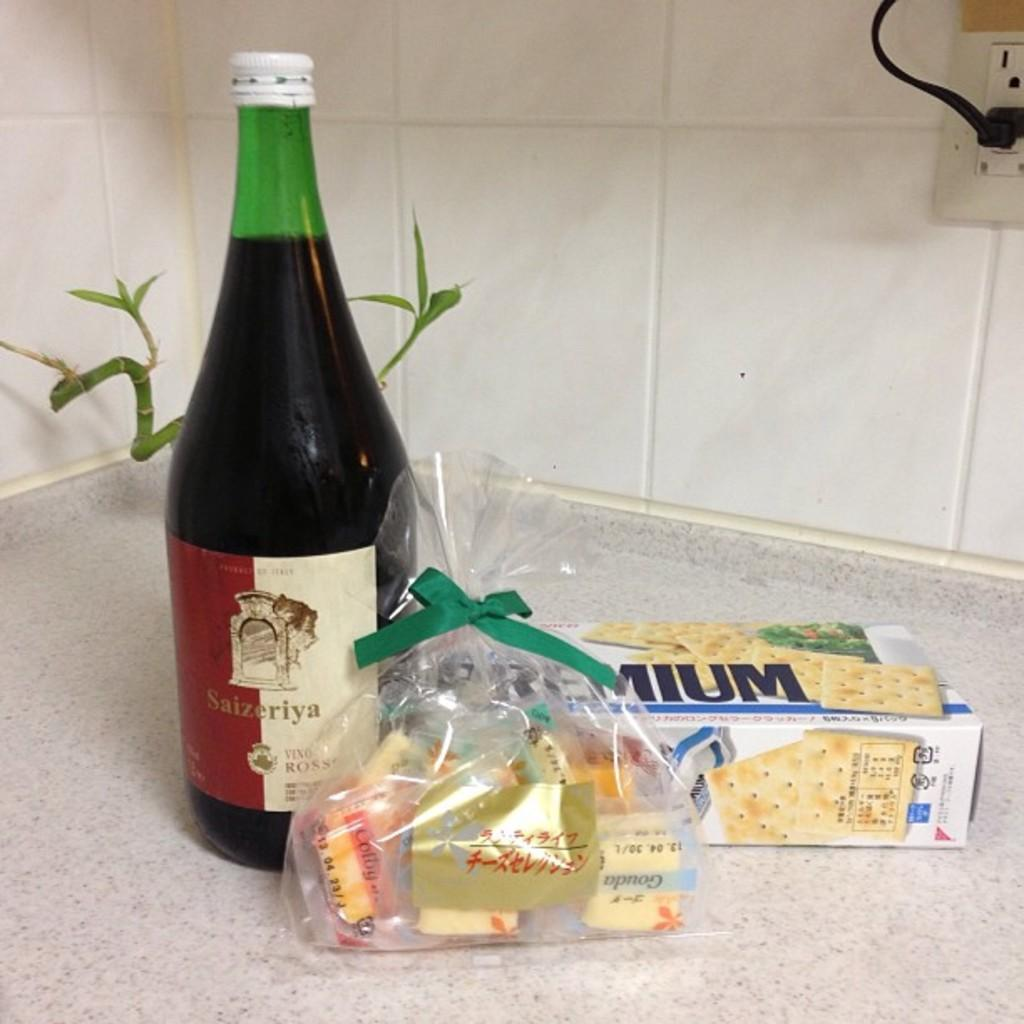<image>
Give a short and clear explanation of the subsequent image. A bottle of Saizeriya wine is on the counter next to premium brand crackers. 